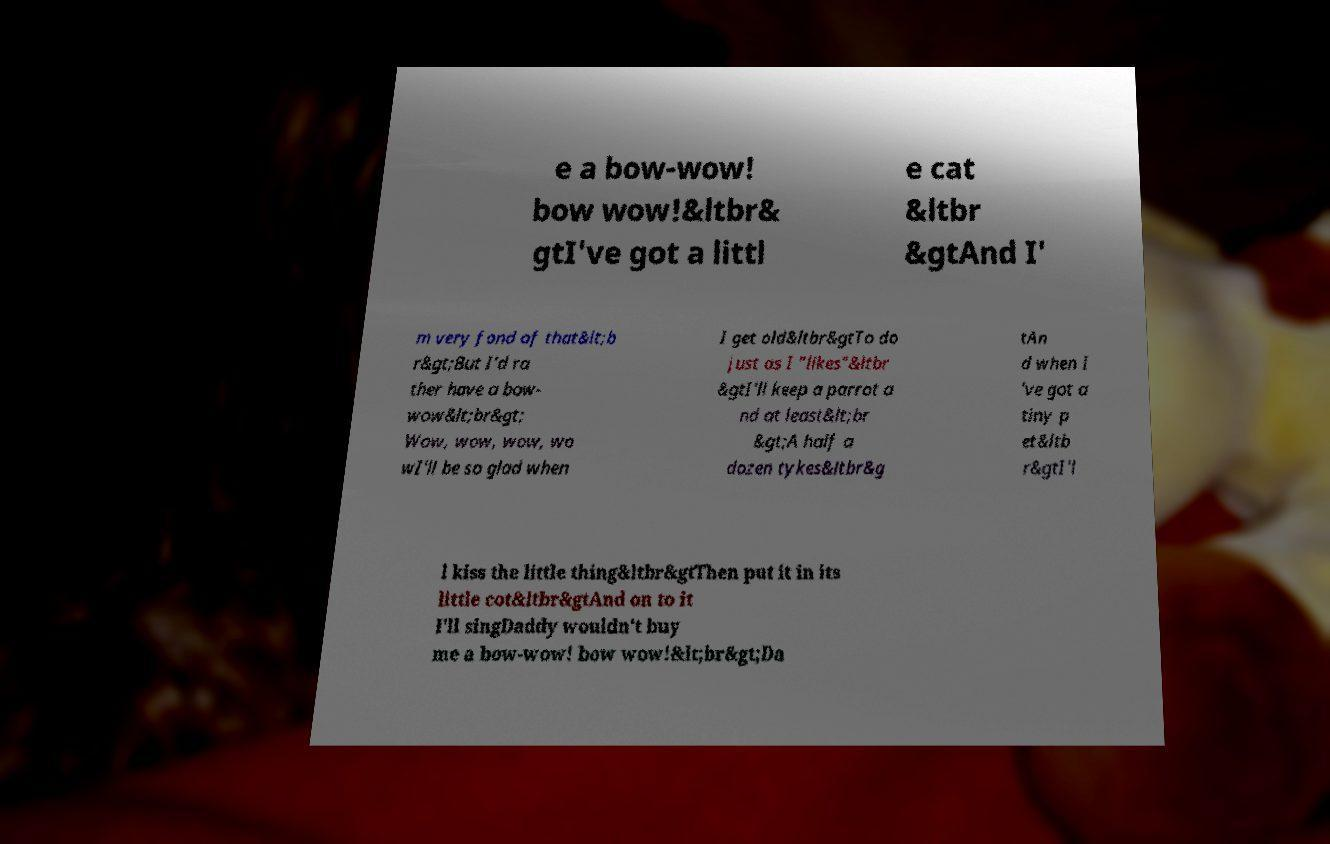I need the written content from this picture converted into text. Can you do that? e a bow-wow! bow wow!&ltbr& gtI've got a littl e cat &ltbr &gtAnd I' m very fond of that&lt;b r&gt;But I'd ra ther have a bow- wow&lt;br&gt; Wow, wow, wow, wo wI'll be so glad when I get old&ltbr&gtTo do just as I "likes"&ltbr &gtI'll keep a parrot a nd at least&lt;br &gt;A half a dozen tykes&ltbr&g tAn d when I 've got a tiny p et&ltb r&gtI'l l kiss the little thing&ltbr&gtThen put it in its little cot&ltbr&gtAnd on to it I'll singDaddy wouldn't buy me a bow-wow! bow wow!&lt;br&gt;Da 